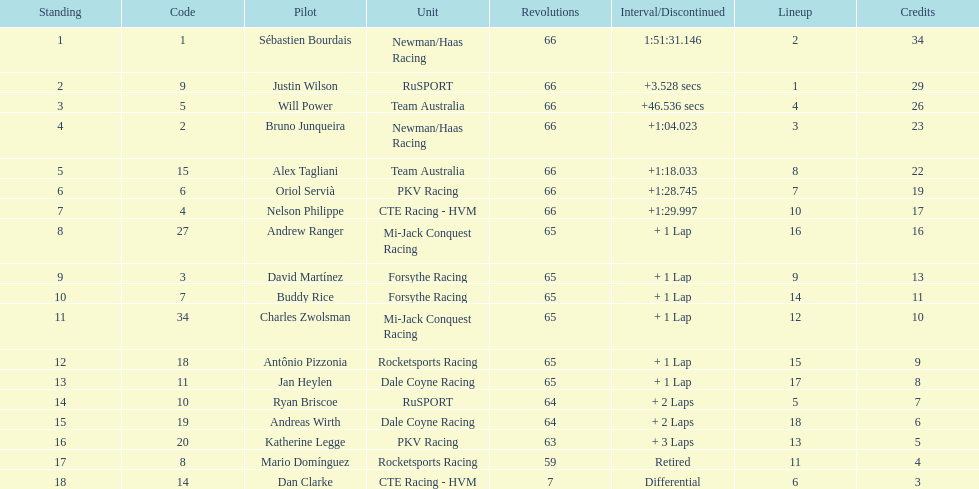At the 2006 gran premio telmex, how many drivers completed less than 60 laps? 2. 